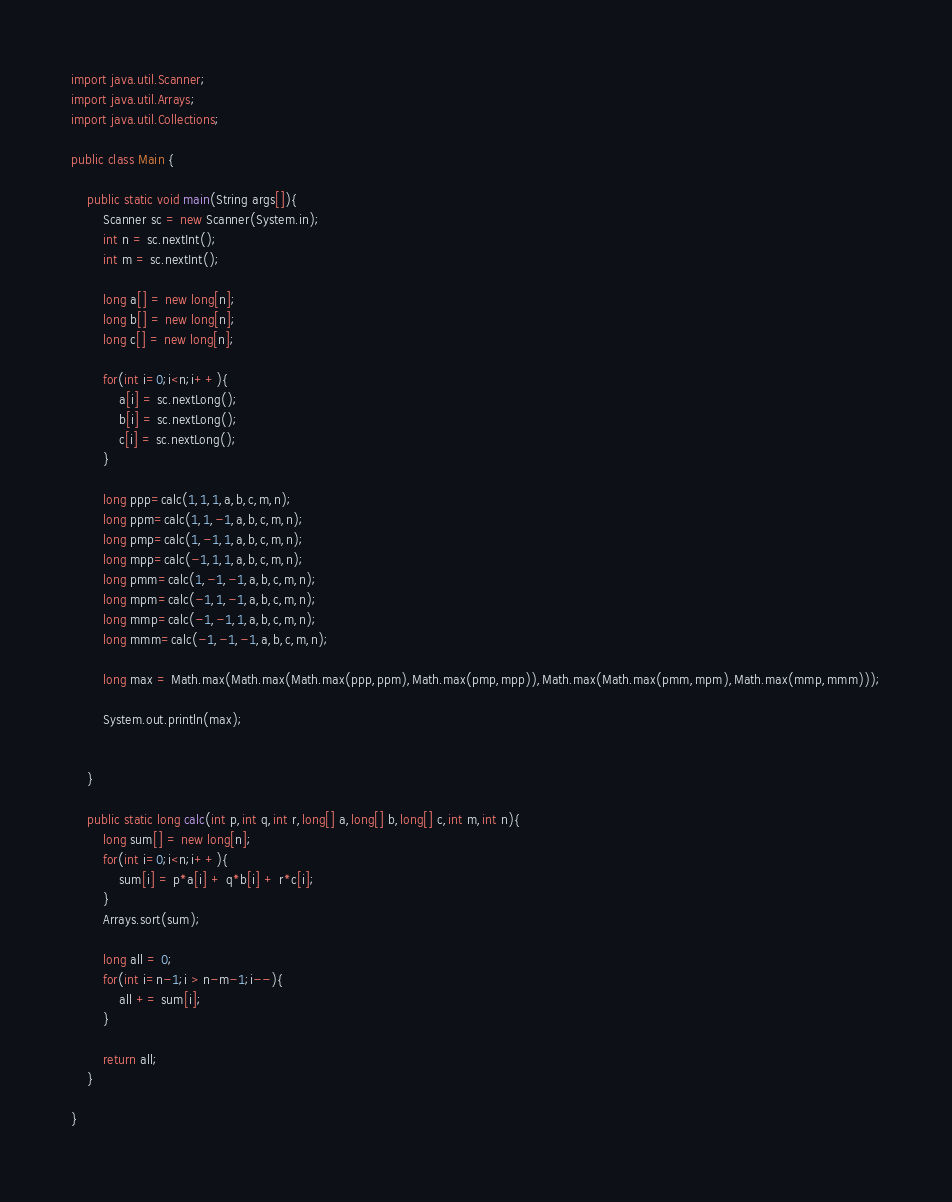Convert code to text. <code><loc_0><loc_0><loc_500><loc_500><_Java_>import java.util.Scanner;
import java.util.Arrays;
import java.util.Collections;

public class Main {
	
	public static void main(String args[]){
		Scanner sc = new Scanner(System.in);
		int n = sc.nextInt();
		int m = sc.nextInt();

		long a[] = new long[n];
		long b[] = new long[n];
		long c[] = new long[n];

		for(int i=0;i<n;i++){
			a[i] = sc.nextLong();
			b[i] = sc.nextLong();
			c[i] = sc.nextLong();
		}

		long ppp=calc(1,1,1,a,b,c,m,n);
		long ppm=calc(1,1,-1,a,b,c,m,n);
		long pmp=calc(1,-1,1,a,b,c,m,n);
		long mpp=calc(-1,1,1,a,b,c,m,n);
		long pmm=calc(1,-1,-1,a,b,c,m,n);
		long mpm=calc(-1,1,-1,a,b,c,m,n);
		long mmp=calc(-1,-1,1,a,b,c,m,n);
		long mmm=calc(-1,-1,-1,a,b,c,m,n);

		long max = Math.max(Math.max(Math.max(ppp,ppm),Math.max(pmp,mpp)),Math.max(Math.max(pmm,mpm),Math.max(mmp,mmm)));

		System.out.println(max);


	}

	public static long calc(int p,int q,int r,long[] a,long[] b,long[] c,int m,int n){
		long sum[] = new long[n];
		for(int i=0;i<n;i++){
			sum[i] = p*a[i] + q*b[i] + r*c[i];
		}
		Arrays.sort(sum);

		long all = 0;
		for(int i=n-1;i > n-m-1;i--){
			all += sum[i];
		}

		return all;
	}
 
}</code> 